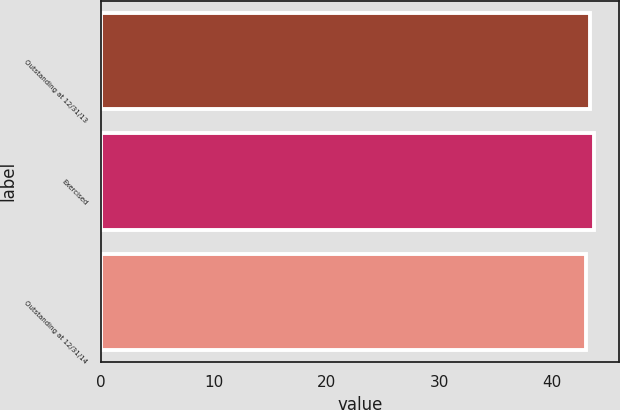<chart> <loc_0><loc_0><loc_500><loc_500><bar_chart><fcel>Outstanding at 12/31/13<fcel>Exercised<fcel>Outstanding at 12/31/14<nl><fcel>43.38<fcel>43.75<fcel>42.99<nl></chart> 